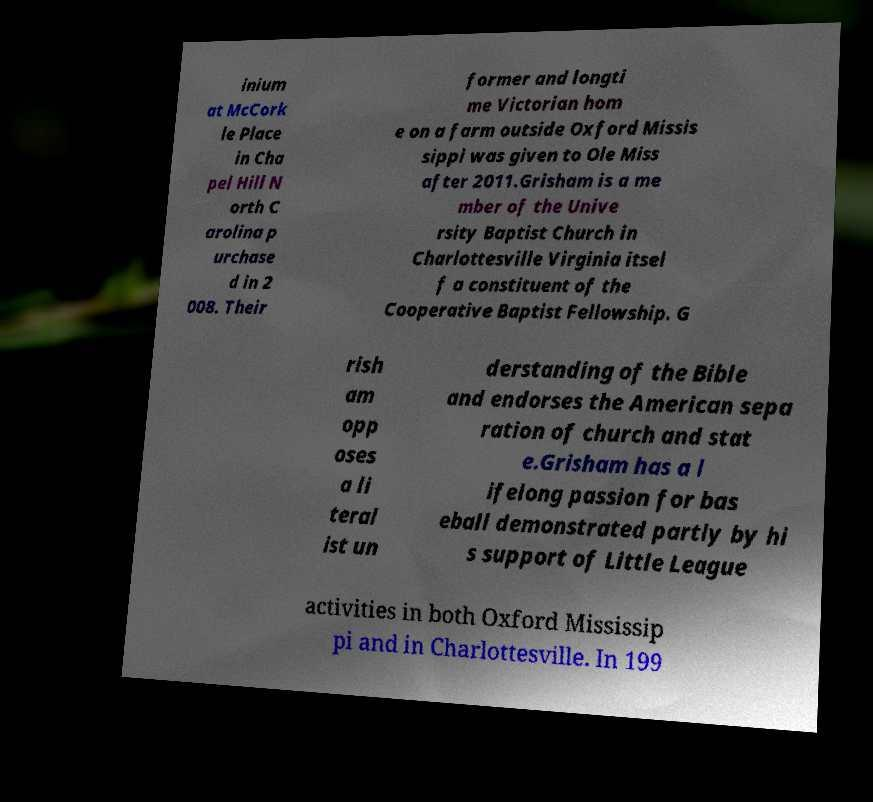Can you read and provide the text displayed in the image?This photo seems to have some interesting text. Can you extract and type it out for me? inium at McCork le Place in Cha pel Hill N orth C arolina p urchase d in 2 008. Their former and longti me Victorian hom e on a farm outside Oxford Missis sippi was given to Ole Miss after 2011.Grisham is a me mber of the Unive rsity Baptist Church in Charlottesville Virginia itsel f a constituent of the Cooperative Baptist Fellowship. G rish am opp oses a li teral ist un derstanding of the Bible and endorses the American sepa ration of church and stat e.Grisham has a l ifelong passion for bas eball demonstrated partly by hi s support of Little League activities in both Oxford Mississip pi and in Charlottesville. In 199 